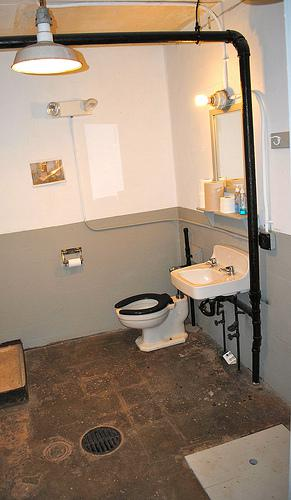Question: how many lights are there?
Choices:
A. Two.
B. One.
C. Three.
D. None.
Answer with the letter. Answer: A Question: what room is this?
Choices:
A. Toilet.
B. Kitchen.
C. Pantry.
D. Bedroom.
Answer with the letter. Answer: A 